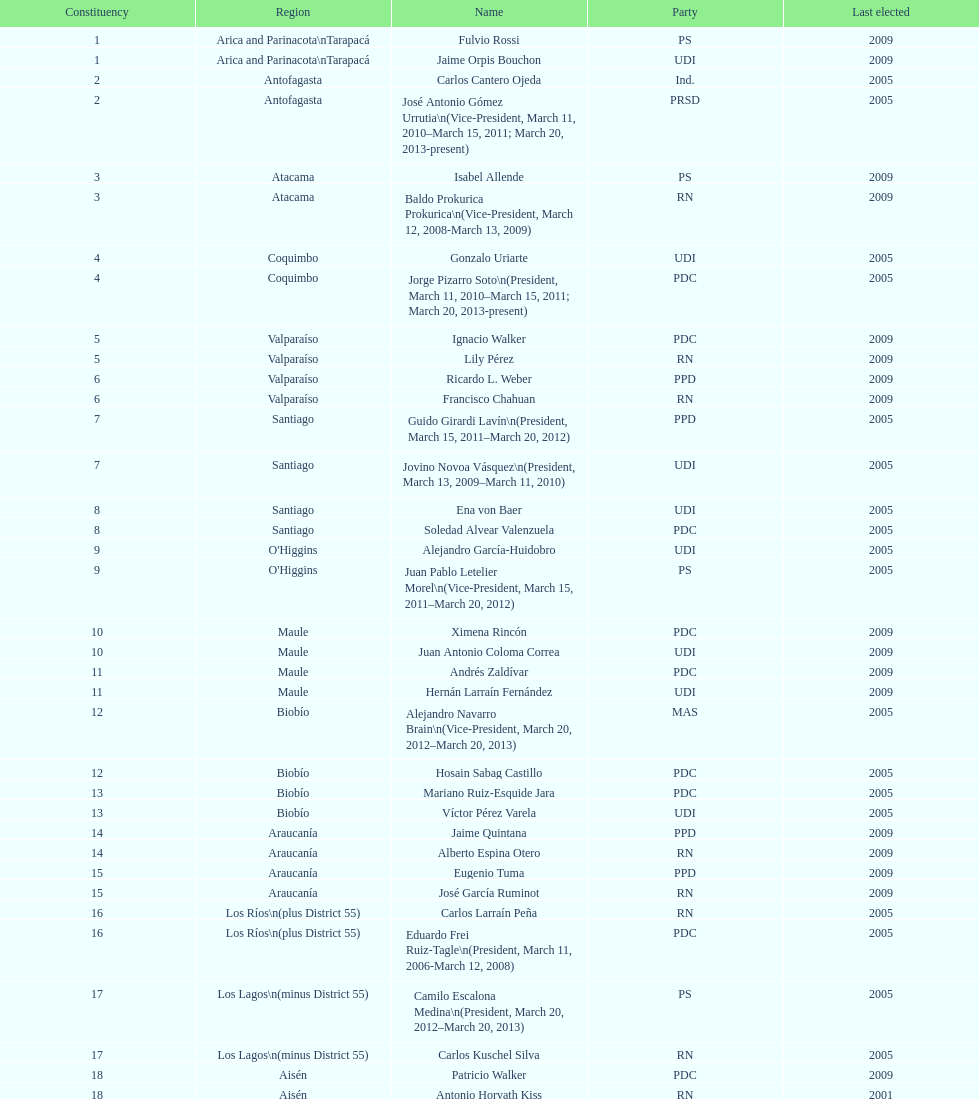What is the difference in years between constiuency 1 and 2? 4 years. 